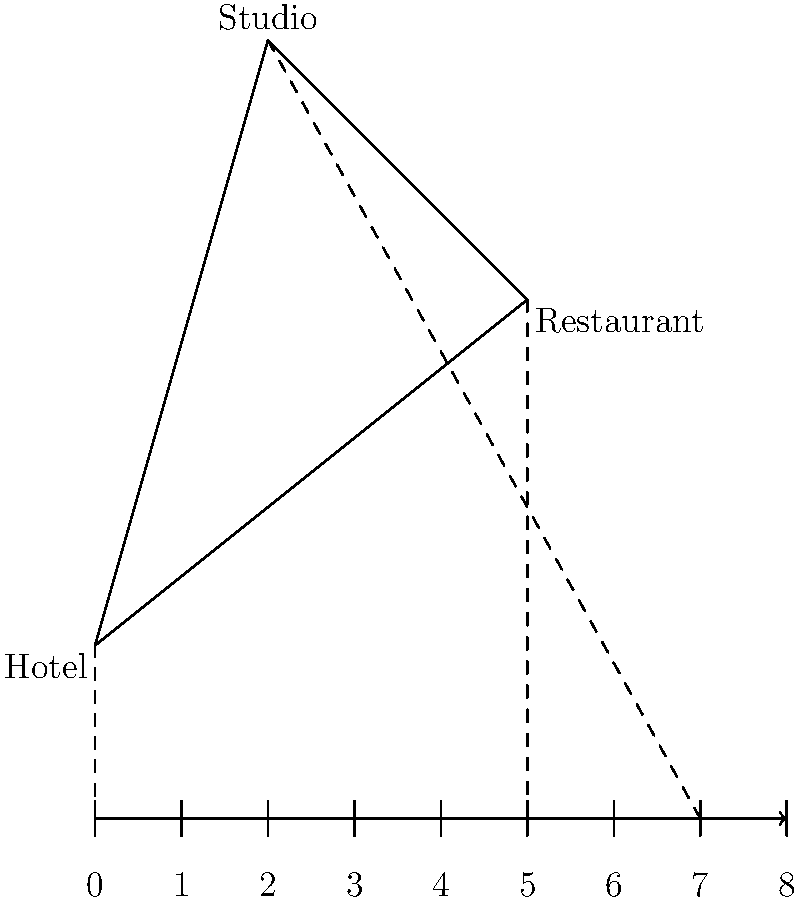A celebrity is scheduled to leave their hotel at 9:00 AM, have lunch at a restaurant at 2:00 PM, and arrive at a studio for an interview at 4:00 PM. Given the map and timeline above, what is the estimated time window (in hours) you have to capture the celebrity's movement between the restaurant and the studio? To solve this problem, we need to follow these steps:

1. Identify the timeline:
   - Hotel departure: 9:00 AM (0 on the timeline)
   - Restaurant arrival: 2:00 PM (5 on the timeline)
   - Studio arrival: 4:00 PM (7 on the timeline)

2. Calculate the time between restaurant and studio:
   $7 - 5 = 2$ hours on the timeline

3. Convert timeline units to actual hours:
   - Total timeline spans 8 units representing 7 hours (4 PM - 9 AM)
   - 1 timeline unit = $\frac{7 \text{ hours}}{8 \text{ units}} = 0.875$ hours

4. Calculate the actual time window:
   $2 \text{ timeline units} \times 0.875 \text{ hours/unit} = 1.75$ hours

Therefore, the estimated time window to capture the celebrity's movement between the restaurant and the studio is 1.75 hours.
Answer: 1.75 hours 